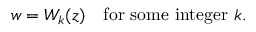Convert formula to latex. <formula><loc_0><loc_0><loc_500><loc_500>w = W _ { k } ( z ) \ \ { f o r s o m e i n t e g e r } k .</formula> 